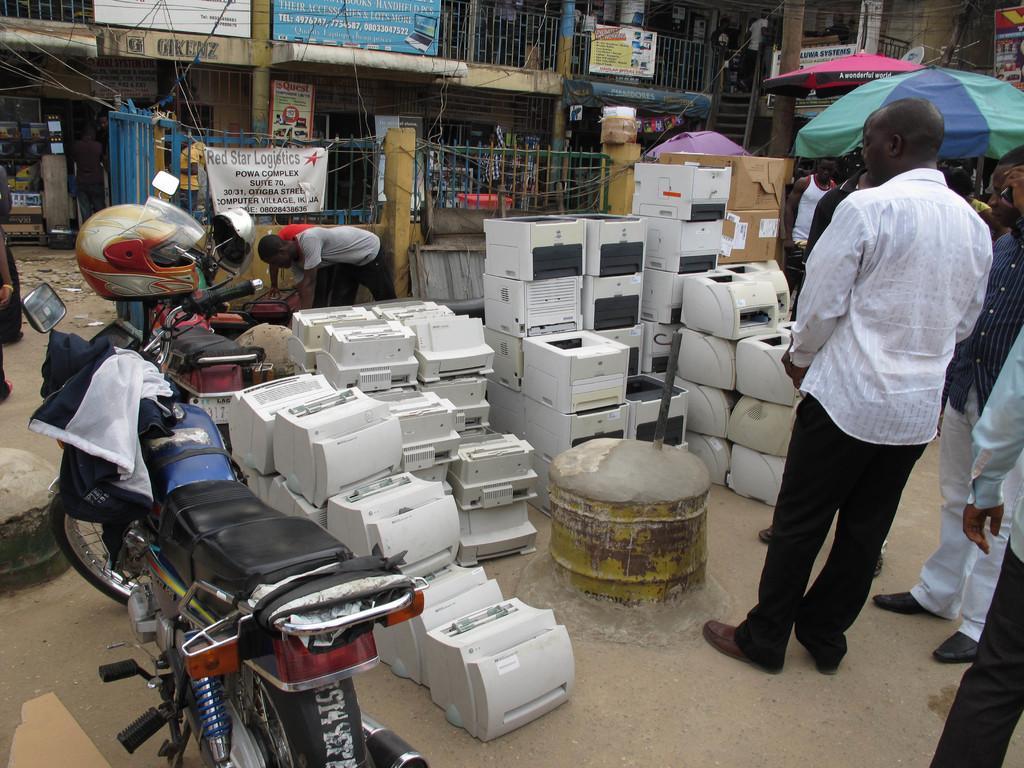Please provide a concise description of this image. In this image we can see machines, people, umbrella, vehicles, helmet and hoardings. These are steps. 